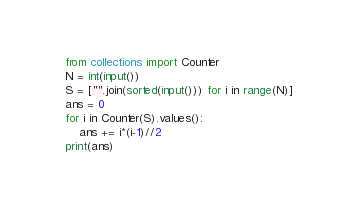Convert code to text. <code><loc_0><loc_0><loc_500><loc_500><_Python_>from collections import Counter
N = int(input())
S = ["".join(sorted(input())) for i in range(N)]
ans = 0
for i in Counter(S).values():
    ans += i*(i-1)//2
print(ans)</code> 